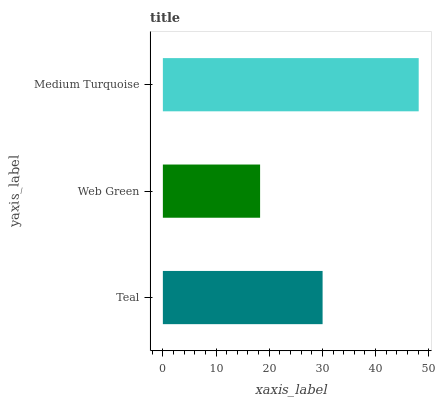Is Web Green the minimum?
Answer yes or no. Yes. Is Medium Turquoise the maximum?
Answer yes or no. Yes. Is Medium Turquoise the minimum?
Answer yes or no. No. Is Web Green the maximum?
Answer yes or no. No. Is Medium Turquoise greater than Web Green?
Answer yes or no. Yes. Is Web Green less than Medium Turquoise?
Answer yes or no. Yes. Is Web Green greater than Medium Turquoise?
Answer yes or no. No. Is Medium Turquoise less than Web Green?
Answer yes or no. No. Is Teal the high median?
Answer yes or no. Yes. Is Teal the low median?
Answer yes or no. Yes. Is Web Green the high median?
Answer yes or no. No. Is Medium Turquoise the low median?
Answer yes or no. No. 